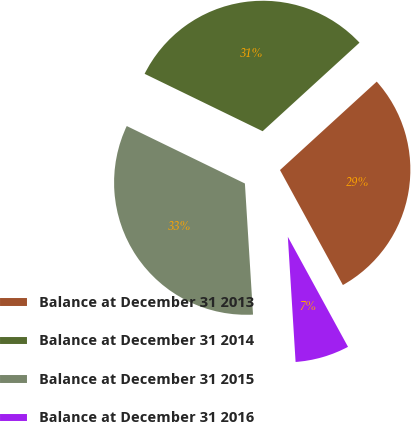Convert chart to OTSL. <chart><loc_0><loc_0><loc_500><loc_500><pie_chart><fcel>Balance at December 31 2013<fcel>Balance at December 31 2014<fcel>Balance at December 31 2015<fcel>Balance at December 31 2016<nl><fcel>28.82%<fcel>31.01%<fcel>33.19%<fcel>6.98%<nl></chart> 